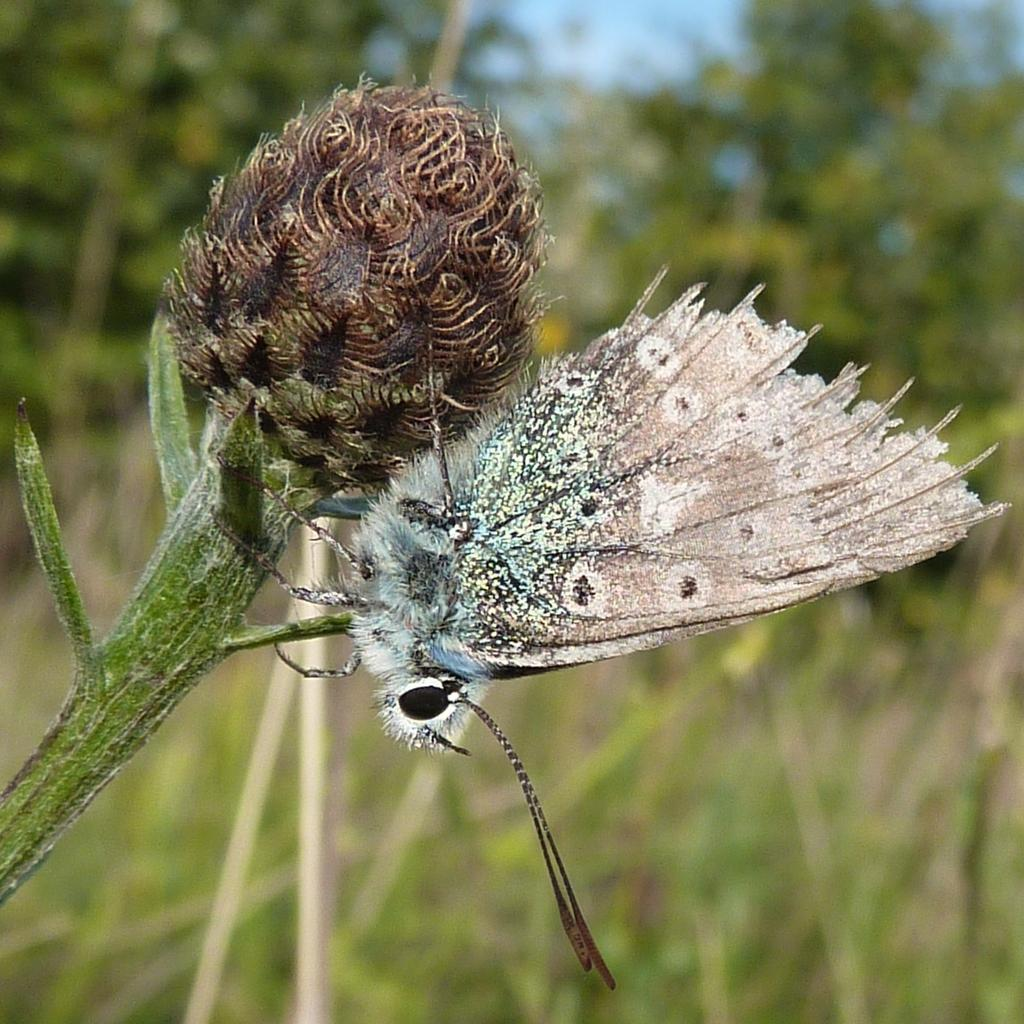What is the main subject of the image? There is a butterfly in the image. Where is the butterfly located? The butterfly is on a stem. What can be seen in the background of the image? There are trees and the sky visible in the background of the image. How would you describe the quality of the image? The image is blurry. How many balls are present on the page in the image? There is no page or balls present in the image; it features a butterfly on a stem with trees and the sky in the background. 